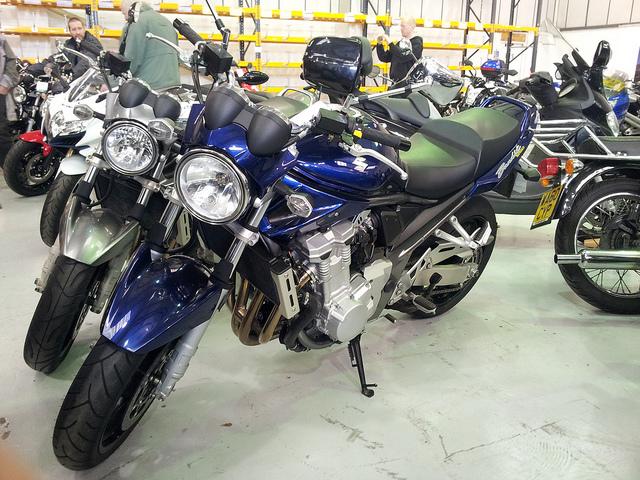Where are the motorcycles?
Quick response, please. In garage. Is there a person in the picture?
Concise answer only. Yes. How many bikes are in the picture?
Concise answer only. 9. 